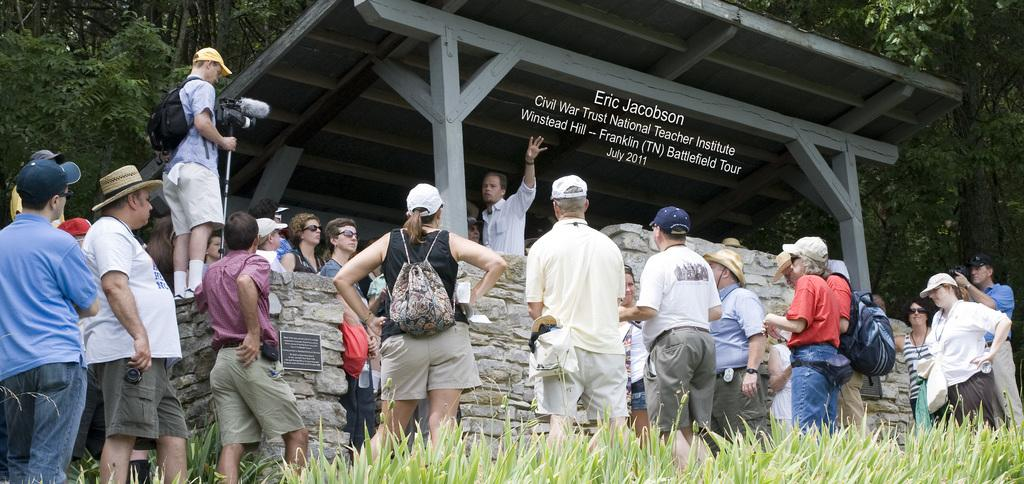How many people are in the image? There is a group of people in the image, but the exact number is not specified. What type of vegetation is present in the image? There are plants in the image. What items are being carried by the people in the image? There are bags in the image. What device is used to capture the image? There is a camera in the image. What type of structure is visible in the image? There is a shed in the image. What architectural feature is present in the image? There is a wall in the image. What additional objects can be seen in the image? There are some objects in the image. Is there any text present in the image? Yes, there is some text in the image. What can be seen in the background of the image? There are trees in the background of the image. What type of underwear is visible on the people in the image? There is no information about underwear in the image, and it is not visible. Can you tell me how many astronauts are in the image? There is no mention of astronauts or space in the image; it features a group of people, plants, bags, a camera, a shed, a wall, some objects, text, and trees in the background. 